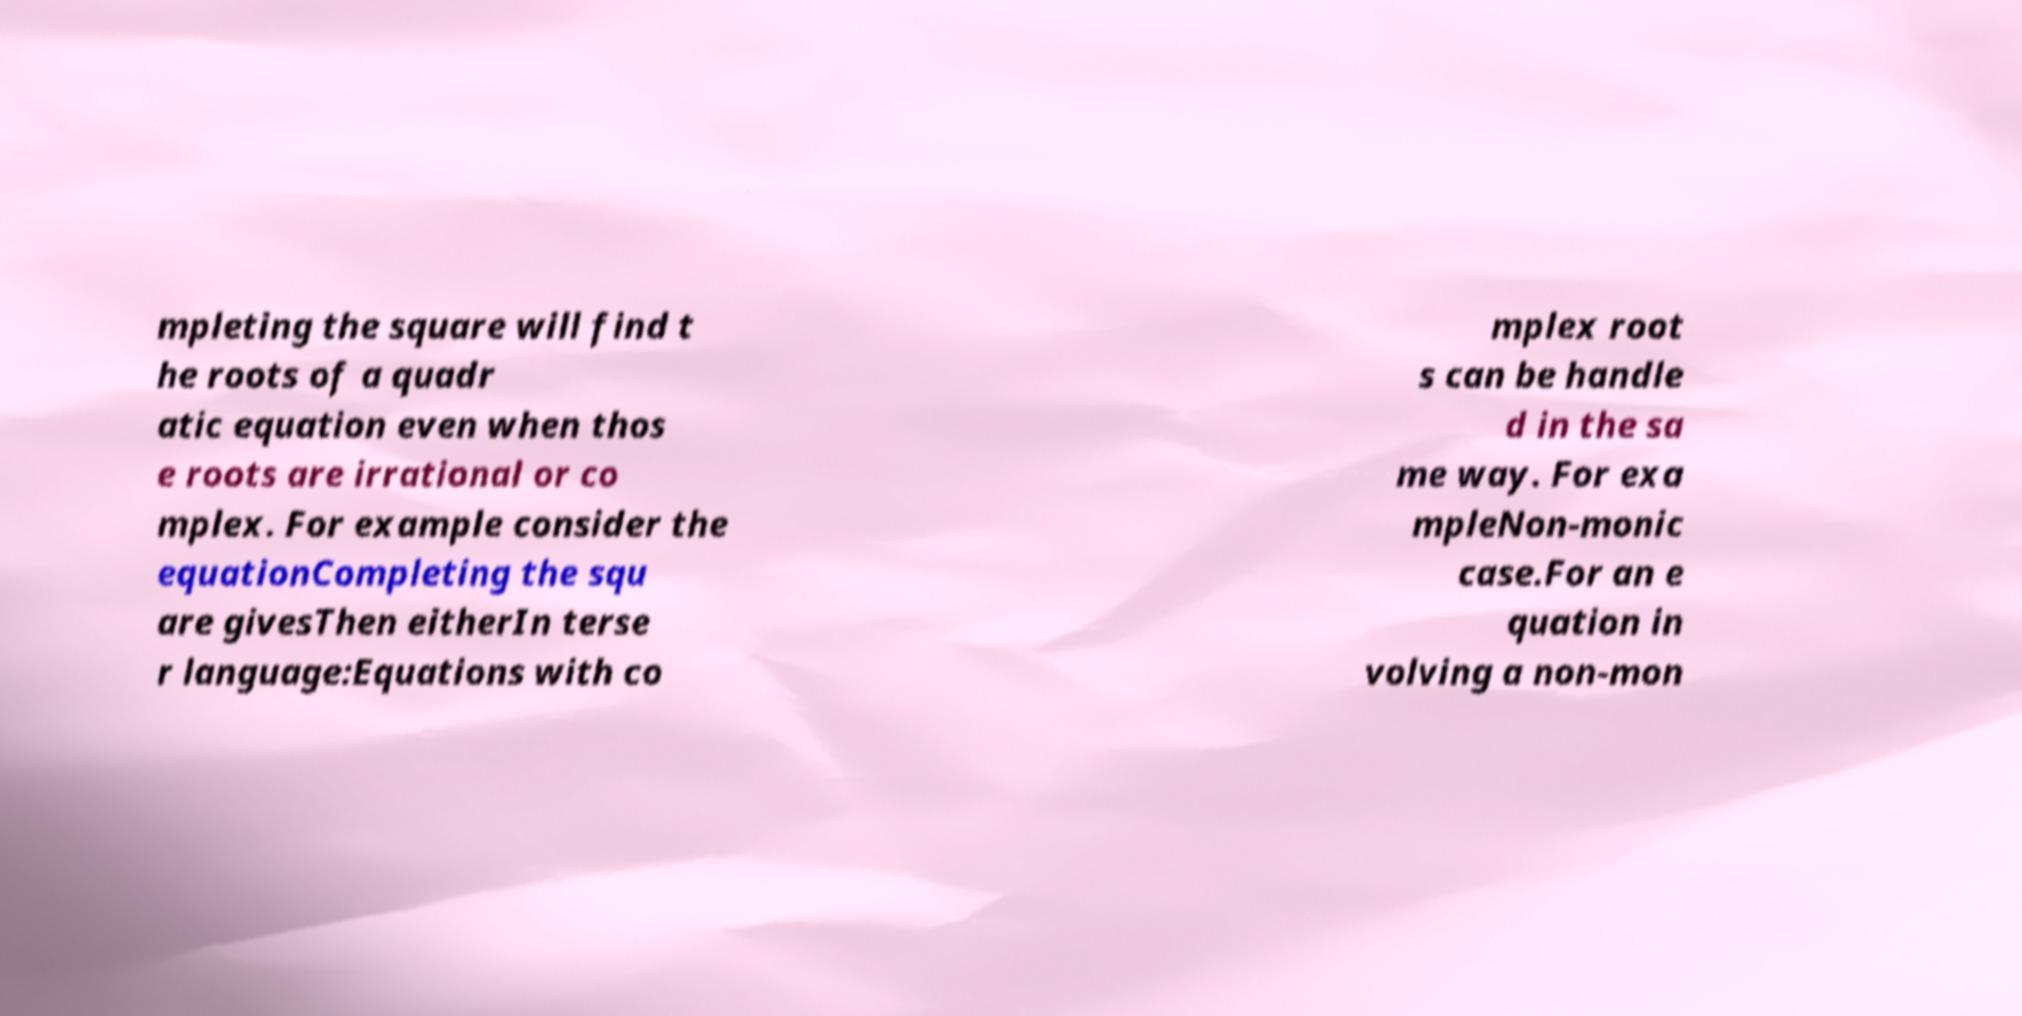I need the written content from this picture converted into text. Can you do that? mpleting the square will find t he roots of a quadr atic equation even when thos e roots are irrational or co mplex. For example consider the equationCompleting the squ are givesThen eitherIn terse r language:Equations with co mplex root s can be handle d in the sa me way. For exa mpleNon-monic case.For an e quation in volving a non-mon 